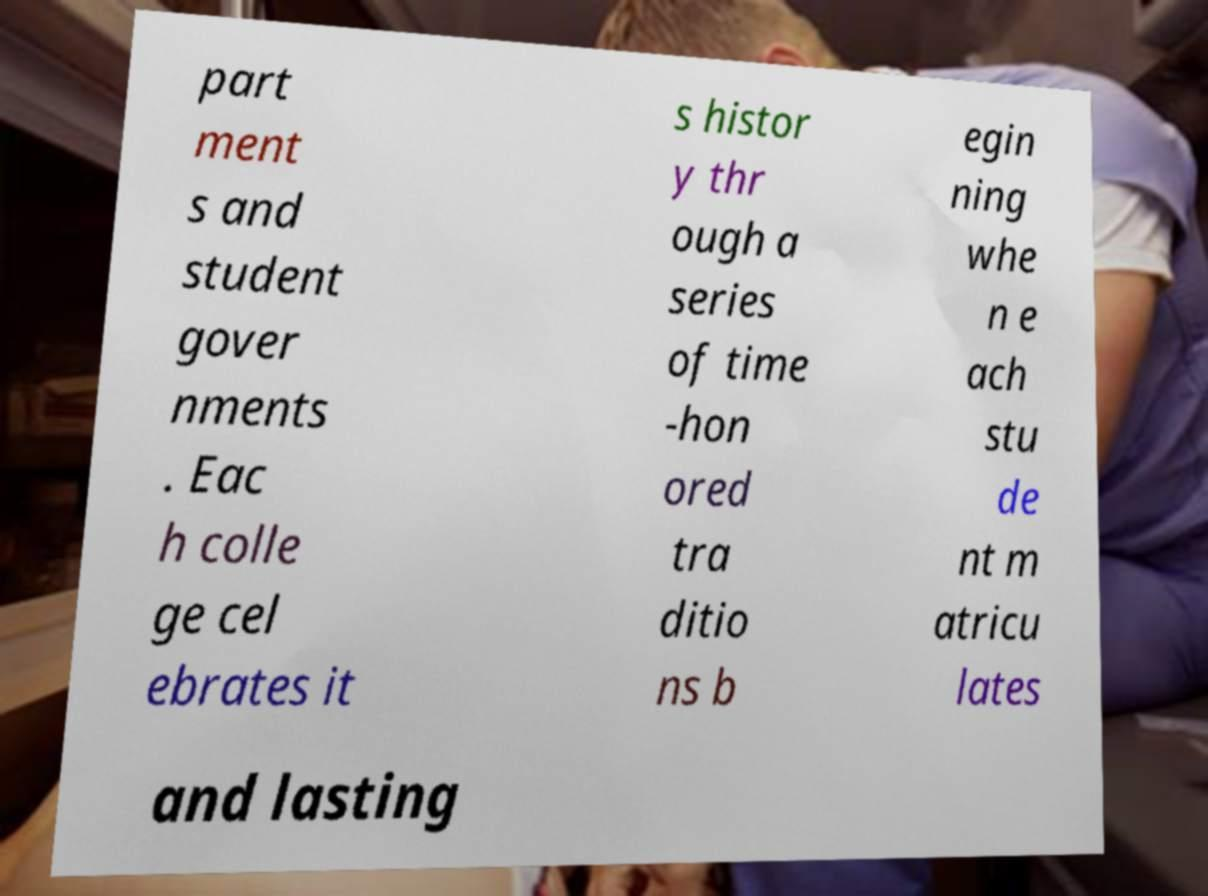Could you assist in decoding the text presented in this image and type it out clearly? part ment s and student gover nments . Eac h colle ge cel ebrates it s histor y thr ough a series of time -hon ored tra ditio ns b egin ning whe n e ach stu de nt m atricu lates and lasting 